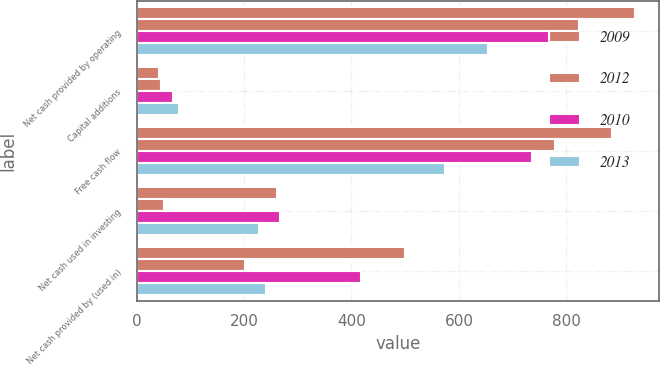<chart> <loc_0><loc_0><loc_500><loc_500><stacked_bar_chart><ecel><fcel>Net cash provided by operating<fcel>Capital additions<fcel>Free cash flow<fcel>Net cash used in investing<fcel>Net cash provided by (used in)<nl><fcel>2009<fcel>926.8<fcel>42.3<fcel>884.5<fcel>261.9<fcel>498.8<nl><fcel>2012<fcel>823.1<fcel>45<fcel>778.1<fcel>50.2<fcel>202.6<nl><fcel>2010<fcel>803.3<fcel>67.7<fcel>735.6<fcel>267.6<fcel>417.7<nl><fcel>2013<fcel>653.3<fcel>79<fcel>574.3<fcel>228.8<fcel>241.3<nl></chart> 